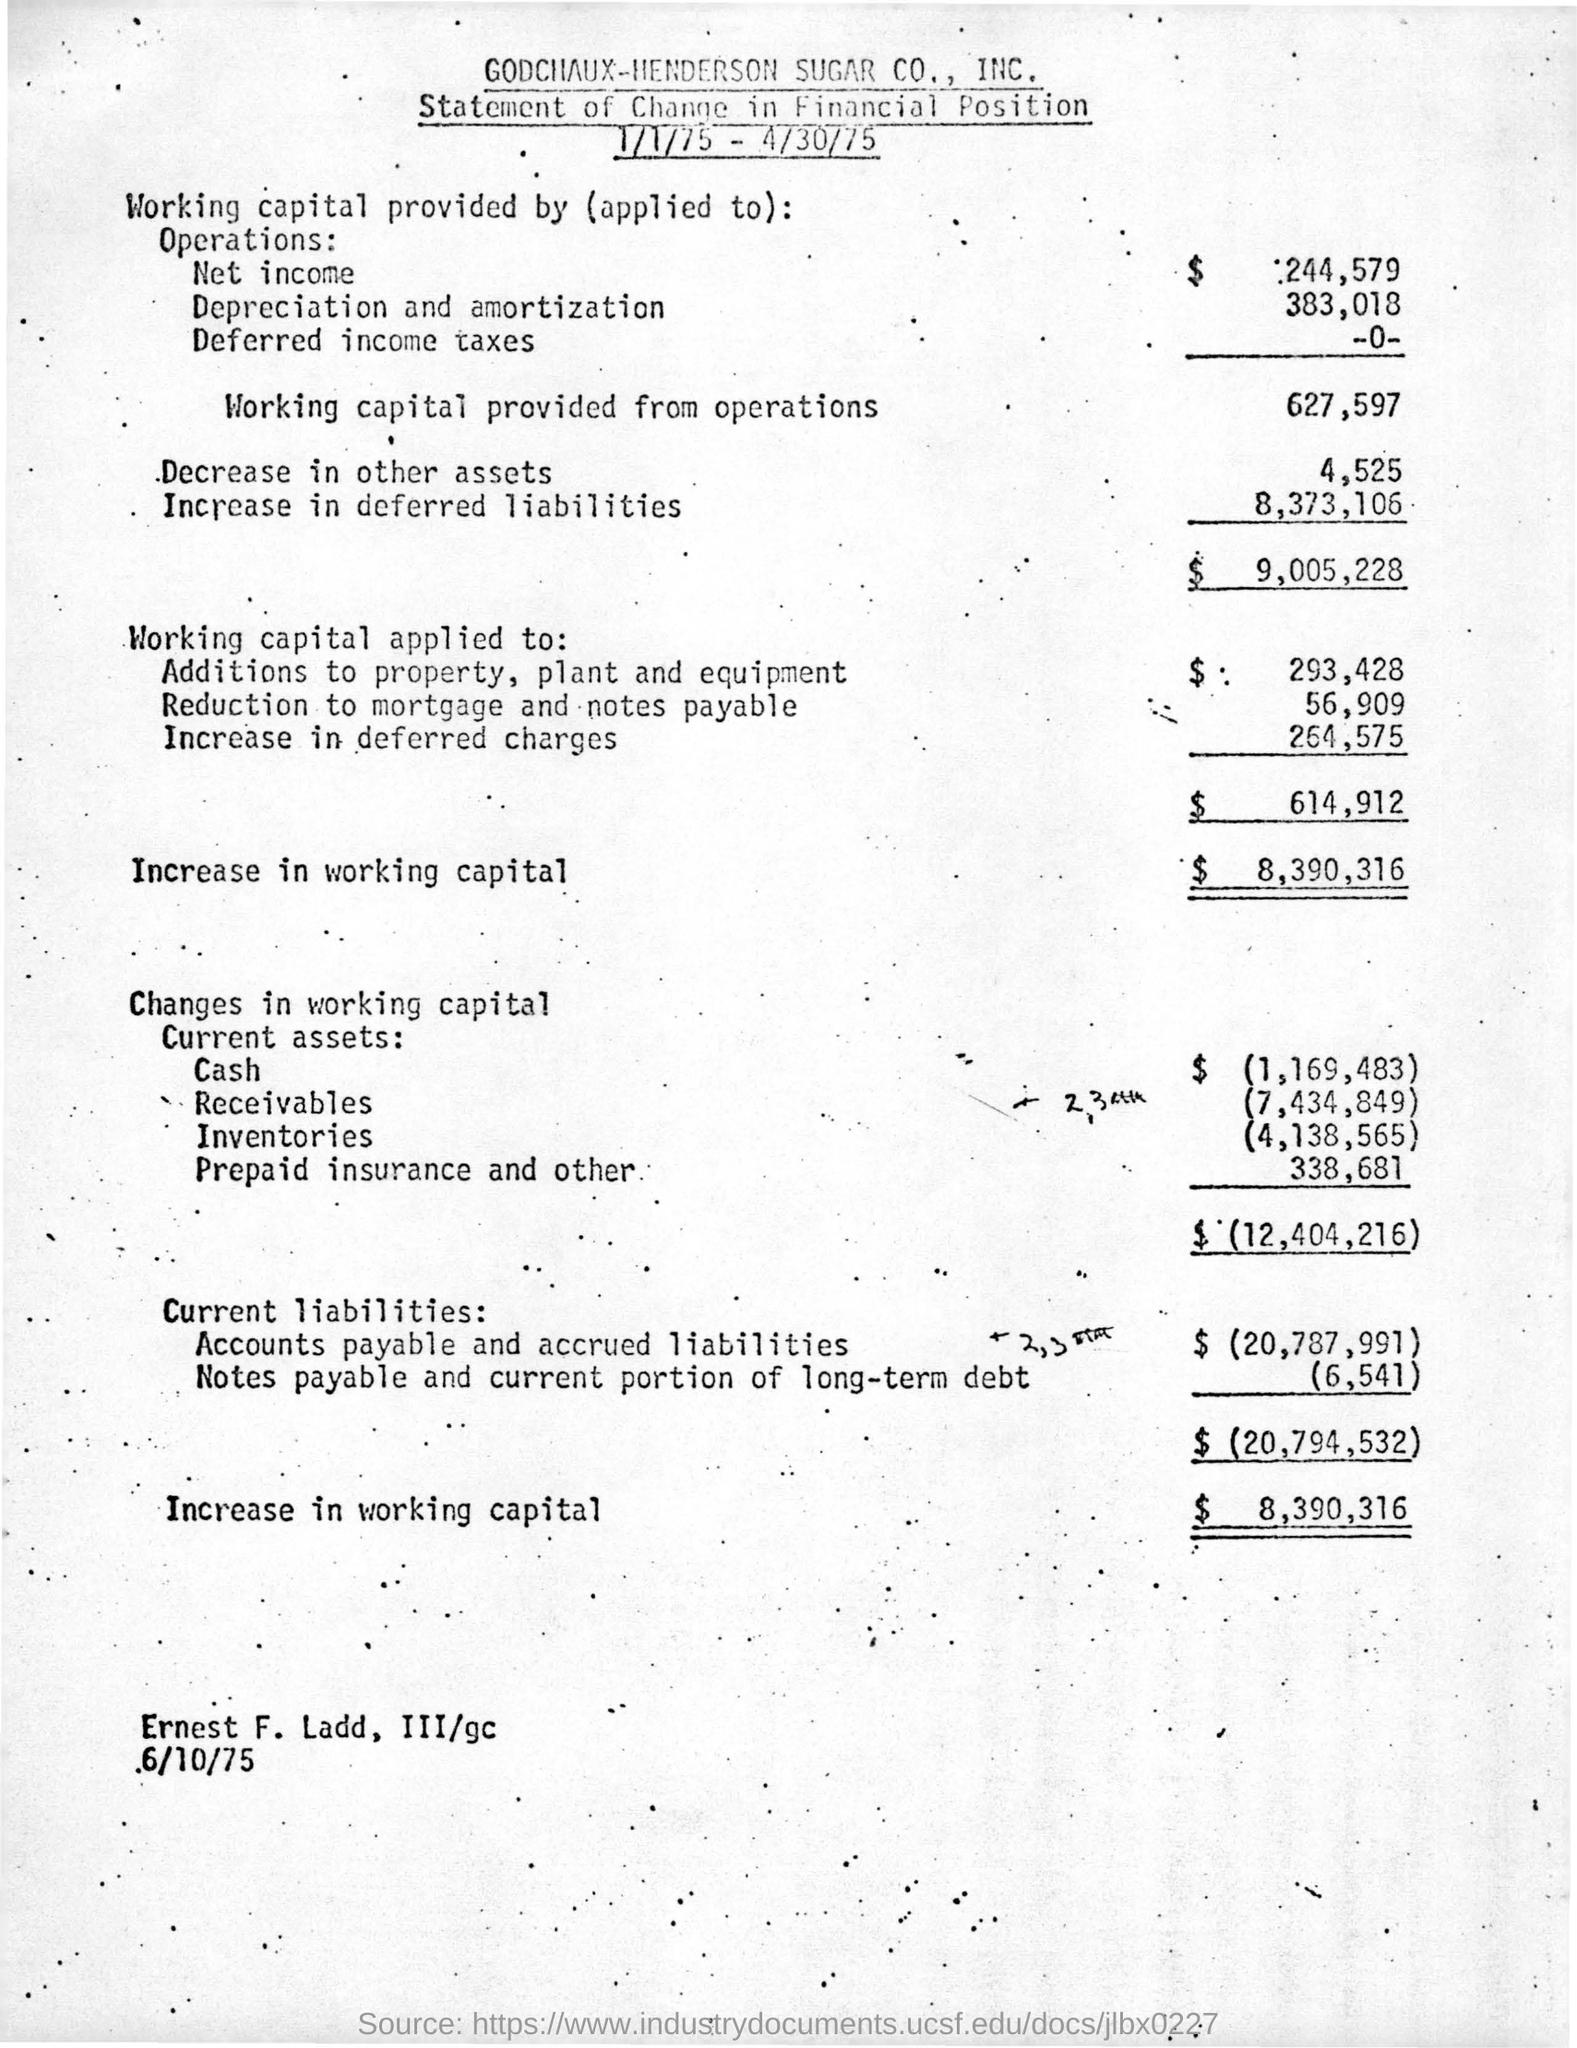Outline some significant characteristics in this image. The given amount of working capital provided from operations is $627,597. The amount of increase in working capital is $8,390,316. The deferred charges increased by $264,575. 